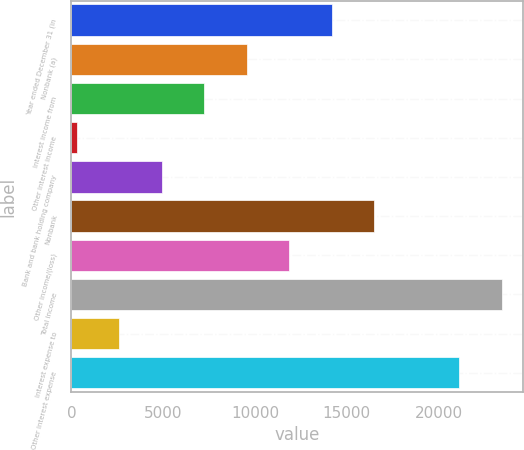Convert chart. <chart><loc_0><loc_0><loc_500><loc_500><bar_chart><fcel>Year ended December 31 (in<fcel>Nonbank (a)<fcel>Interest income from<fcel>Other interest income<fcel>Bank and bank holding company<fcel>Nonbank<fcel>Other income/(loss)<fcel>Total income<fcel>Interest expense to<fcel>Other interest expense<nl><fcel>14188.2<fcel>9559.8<fcel>7245.6<fcel>303<fcel>4931.4<fcel>16502.4<fcel>11874<fcel>23445<fcel>2617.2<fcel>21130.8<nl></chart> 